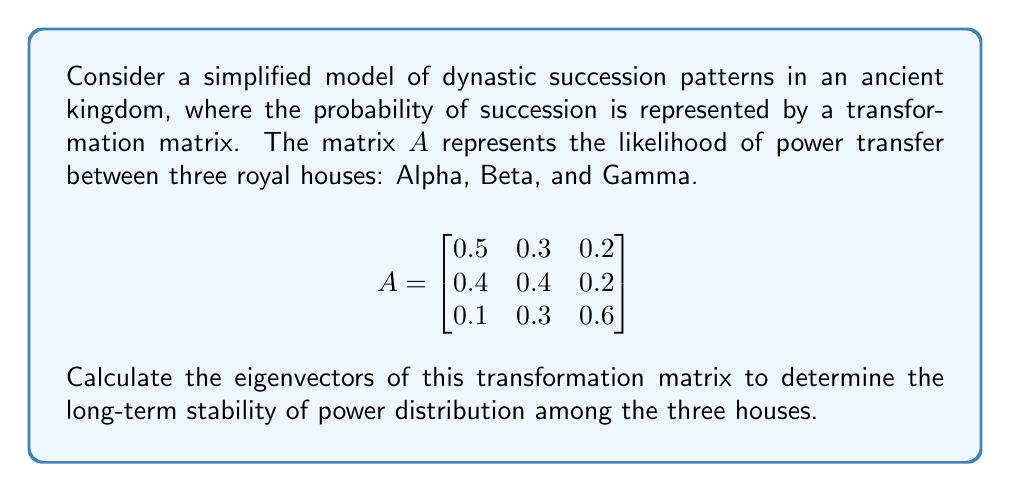Could you help me with this problem? To find the eigenvectors of matrix $A$, we follow these steps:

1) First, we need to find the eigenvalues by solving the characteristic equation:
   $\det(A - \lambda I) = 0$

2) Expanding the determinant:
   $$\begin{vmatrix}
   0.5-\lambda & 0.3 & 0.2 \\
   0.4 & 0.4-\lambda & 0.2 \\
   0.1 & 0.3 & 0.6-\lambda
   \end{vmatrix} = 0$$

3) This gives us the cubic equation:
   $-\lambda^3 + 1.5\lambda^2 - 0.7\lambda + 0.1 = 0$

4) Solving this equation (using a computer algebra system or numerical methods), we get the eigenvalues:
   $\lambda_1 = 1$, $\lambda_2 \approx 0.3819$, $\lambda_3 \approx 0.1181$

5) For each eigenvalue, we solve $(A - \lambda I)v = 0$ to find the corresponding eigenvector.

6) For $\lambda_1 = 1$:
   $$\begin{bmatrix}
   -0.5 & 0.3 & 0.2 \\
   0.4 & -0.6 & 0.2 \\
   0.1 & 0.3 & -0.4
   \end{bmatrix} \begin{bmatrix} v_1 \\ v_2 \\ v_3 \end{bmatrix} = \begin{bmatrix} 0 \\ 0 \\ 0 \end{bmatrix}$$

   Solving this system gives us the eigenvector $v_1 \approx (0.4545, 0.4545, 0.0909)^T$

7) For $\lambda_2 \approx 0.3819$:
   Solving the corresponding system gives $v_2 \approx (-0.7891, 0.5600, 0.2532)^T$

8) For $\lambda_3 \approx 0.1181$:
   Solving the corresponding system gives $v_3 \approx (0.4364, -0.8536, 0.2843)^T$

These eigenvectors represent the long-term power distribution patterns among the three houses. The eigenvector corresponding to the largest eigenvalue (1 in this case) is particularly significant as it represents the stable power distribution if this succession pattern continues indefinitely.
Answer: The eigenvectors of the transformation matrix are:

$v_1 \approx (0.4545, 0.4545, 0.0909)^T$
$v_2 \approx (-0.7891, 0.5600, 0.2532)^T$
$v_3 \approx (0.4364, -0.8536, 0.2843)^T$

The most significant eigenvector is $v_1$, corresponding to $\lambda_1 = 1$, which indicates a stable power distribution of approximately 45.45% for House Alpha, 45.45% for House Beta, and 9.09% for House Gamma in the long term. 